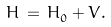<formula> <loc_0><loc_0><loc_500><loc_500>H _ { \L } \, = \, H _ { 0 } ^ { \L } + V ^ { \L } .</formula> 